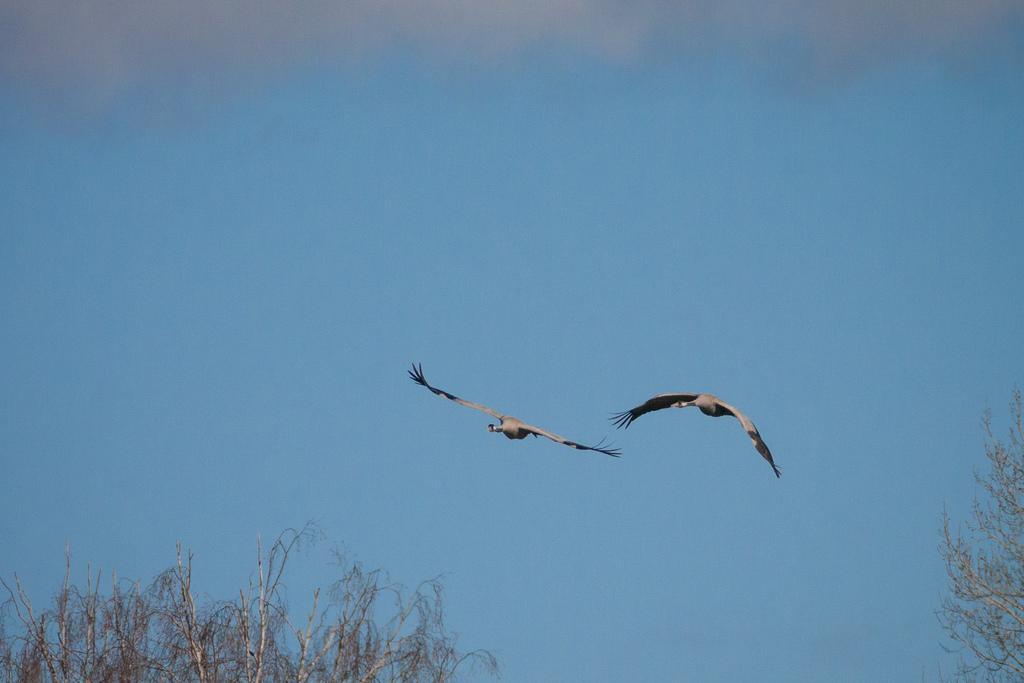Can you describe this image briefly? In this image there are two birds in the air. There are trees. In the background of the image there is sky. 